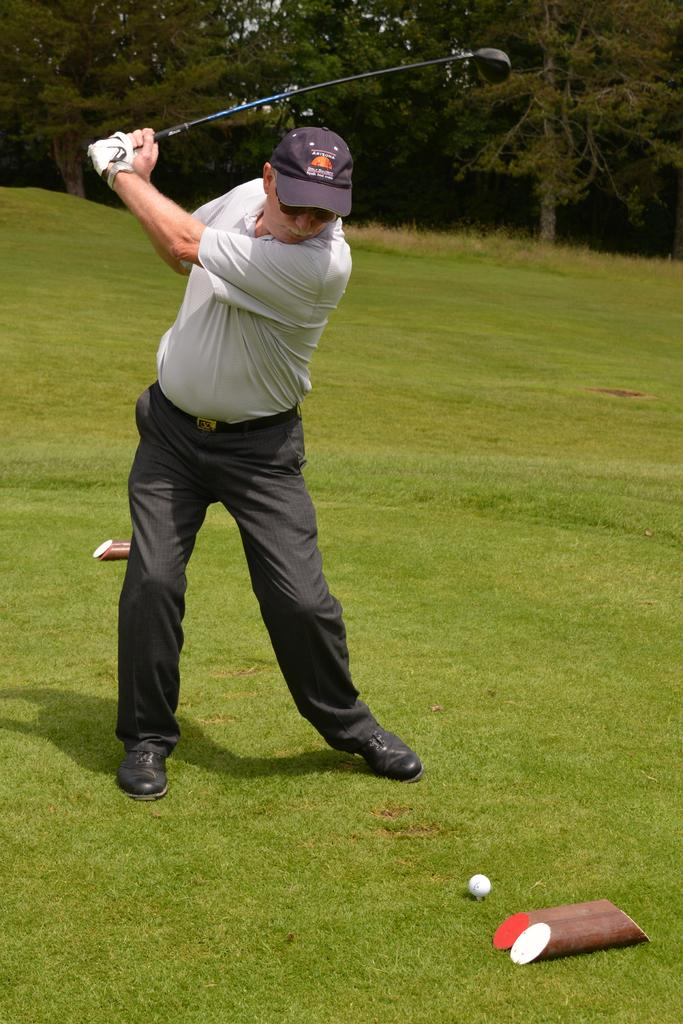What is the person in the image doing? The person is standing on the ground and holding a stick. What object is on the ground near the person? There is a ball on the ground in the image. What can be seen in the background of the image? Trees are visible in the background of the image. What rule is being enforced by the person holding the stick in the image? There is no indication in the image that the person holding the stick is enforcing any rules. 